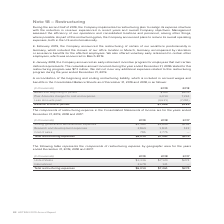According to Adtran's financial document, Why did the company implement a restructuring plan in 2019? to realign its expense structure with the reduction in revenue experienced in recent years and overall Company objectives.. The document states: "2019, the Company implemented a restructuring plan to realign its expense structure with the reduction in revenue experienced in recent years and over..." Also, What was the balance at the beginning of period in 2019? According to the financial document, $185 (in thousands). The relevant text states: "Balance at beginning of period $185 $205..." Also, What was the balance at the end of period in 2019? According to the financial document, $1,568 (in thousands). The relevant text states: "Balance at end of period $1,568 $185..." Also, can you calculate: What was the change in the balance at the beginning of the period and end of the period in 2019? Based on the calculation: $1,568-$185, the result is 1383 (in thousands). This is based on the information: "Balance at end of period $1,568 $185 Balance at end of period $1,568 $185..." The key data points involved are: 1,568, 185. Also, can you calculate: What was the change in Amounts charged to cost and expense between 2018 and 2019? Based on the calculation: 6,014-7,261, the result is -1247 (in thousands). This is based on the information: "Plus: Amounts charged to cost and expense 6,014 7,261 Plus: Amounts charged to cost and expense 6,014 7,261..." The key data points involved are: 6,014, 7,261. Additionally, Which year had a larger change in  Balance at beginning of period to  Balance at end of period? According to the financial document, 2019. The relevant text states: "(In thousands) 2019 2018..." 